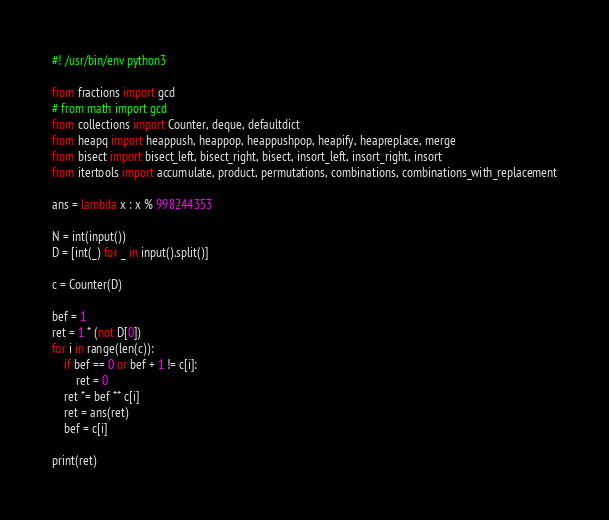<code> <loc_0><loc_0><loc_500><loc_500><_Python_>#! /usr/bin/env python3

from fractions import gcd
# from math import gcd
from collections import Counter, deque, defaultdict
from heapq import heappush, heappop, heappushpop, heapify, heapreplace, merge
from bisect import bisect_left, bisect_right, bisect, insort_left, insort_right, insort
from itertools import accumulate, product, permutations, combinations, combinations_with_replacement

ans = lambda x : x % 998244353

N = int(input())
D = [int(_) for _ in input().split()]

c = Counter(D)

bef = 1
ret = 1 * (not D[0])
for i in range(len(c)):
    if bef == 0 or bef + 1 != c[i]:
        ret = 0
    ret *= bef ** c[i]
    ret = ans(ret)
    bef = c[i]

print(ret)</code> 